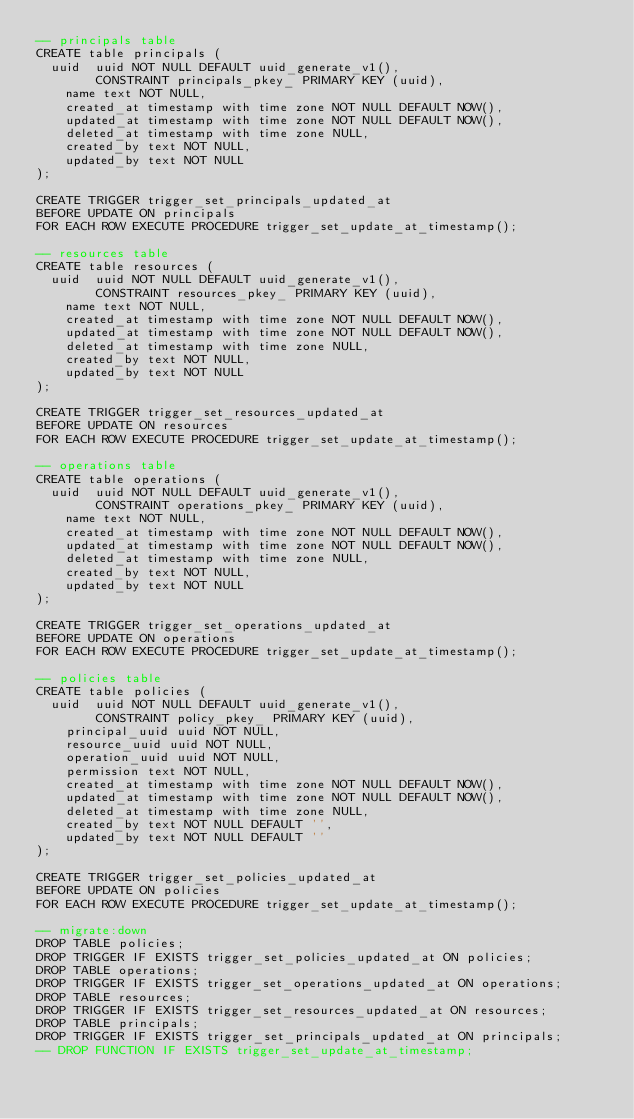Convert code to text. <code><loc_0><loc_0><loc_500><loc_500><_SQL_>-- principals table
CREATE table principals (
	uuid  uuid NOT NULL DEFAULT uuid_generate_v1(),  
        CONSTRAINT principals_pkey_ PRIMARY KEY (uuid),
    name text NOT NULL,
    created_at timestamp with time zone NOT NULL DEFAULT NOW(),
    updated_at timestamp with time zone NOT NULL DEFAULT NOW(),
    deleted_at timestamp with time zone NULL,
    created_by text NOT NULL, 
    updated_by text NOT NULL
);

CREATE TRIGGER trigger_set_principals_updated_at
BEFORE UPDATE ON principals
FOR EACH ROW EXECUTE PROCEDURE trigger_set_update_at_timestamp();

-- resources table
CREATE table resources (
	uuid  uuid NOT NULL DEFAULT uuid_generate_v1(),  
        CONSTRAINT resources_pkey_ PRIMARY KEY (uuid),
    name text NOT NULL,
    created_at timestamp with time zone NOT NULL DEFAULT NOW(),
    updated_at timestamp with time zone NOT NULL DEFAULT NOW(),
    deleted_at timestamp with time zone NULL,
    created_by text NOT NULL, 
    updated_by text NOT NULL
);

CREATE TRIGGER trigger_set_resources_updated_at
BEFORE UPDATE ON resources
FOR EACH ROW EXECUTE PROCEDURE trigger_set_update_at_timestamp();

-- operations table
CREATE table operations (
	uuid  uuid NOT NULL DEFAULT uuid_generate_v1(),  
        CONSTRAINT operations_pkey_ PRIMARY KEY (uuid),
    name text NOT NULL,
    created_at timestamp with time zone NOT NULL DEFAULT NOW(),
    updated_at timestamp with time zone NOT NULL DEFAULT NOW(),
    deleted_at timestamp with time zone NULL,
    created_by text NOT NULL, 
    updated_by text NOT NULL
);

CREATE TRIGGER trigger_set_operations_updated_at
BEFORE UPDATE ON operations
FOR EACH ROW EXECUTE PROCEDURE trigger_set_update_at_timestamp();

-- policies table
CREATE table policies (
	uuid  uuid NOT NULL DEFAULT uuid_generate_v1(),  
        CONSTRAINT policy_pkey_ PRIMARY KEY (uuid),
    principal_uuid uuid NOT NULL,
    resource_uuid uuid NOT NULL,
    operation_uuid uuid NOT NULL,
    permission text NOT NULL,
    created_at timestamp with time zone NOT NULL DEFAULT NOW(),
    updated_at timestamp with time zone NOT NULL DEFAULT NOW(),
    deleted_at timestamp with time zone NULL,
    created_by text NOT NULL DEFAULT '', 
    updated_by text NOT NULL DEFAULT ''
);

CREATE TRIGGER trigger_set_policies_updated_at
BEFORE UPDATE ON policies
FOR EACH ROW EXECUTE PROCEDURE trigger_set_update_at_timestamp();

-- migrate:down
DROP TABLE policies;
DROP TRIGGER IF EXISTS trigger_set_policies_updated_at ON policies;
DROP TABLE operations;
DROP TRIGGER IF EXISTS trigger_set_operations_updated_at ON operations;
DROP TABLE resources;
DROP TRIGGER IF EXISTS trigger_set_resources_updated_at ON resources;
DROP TABLE principals;
DROP TRIGGER IF EXISTS trigger_set_principals_updated_at ON principals;
-- DROP FUNCTION IF EXISTS trigger_set_update_at_timestamp;
</code> 